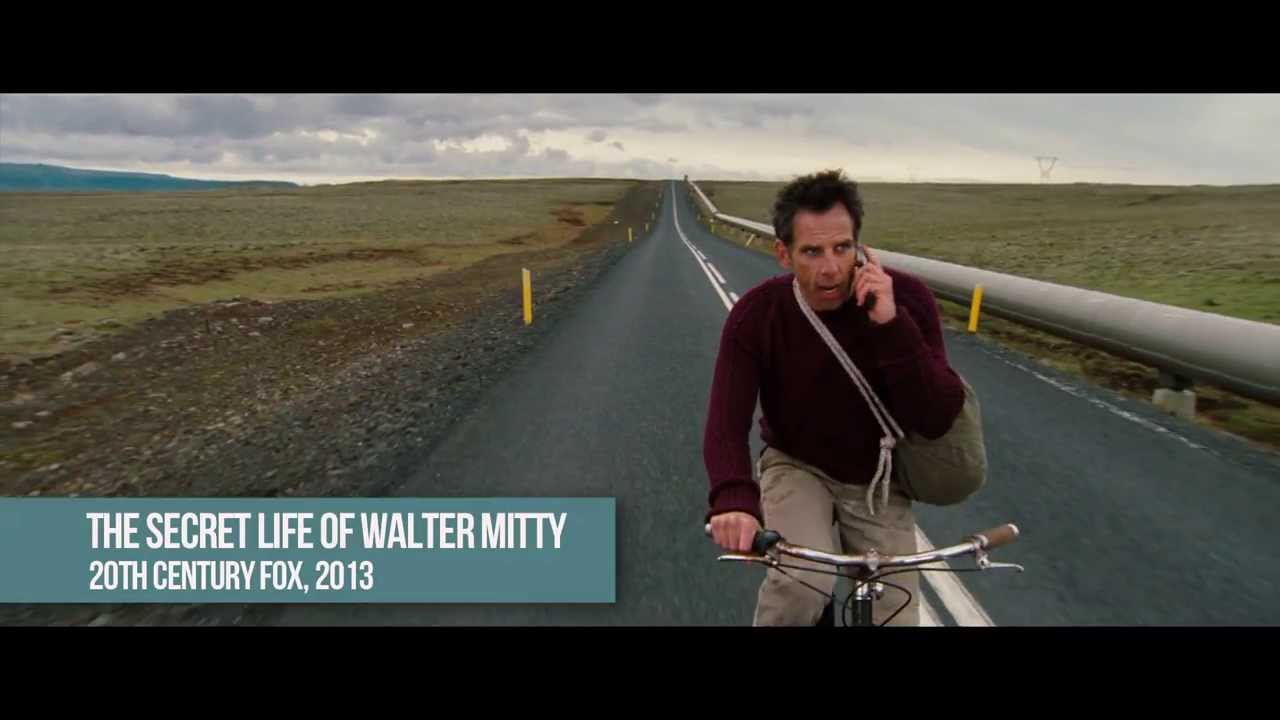Create a short, realistic scenario based on this image. Jacob, a research scientist, left his car behind and opted for his old bicycle after realizing it would be a faster way through the narrow, winding paths leading to the remote testing site. The gloomy skies above promised more rain, but he couldn't risk being late. A critical experiment rested on his shoulders, and even minor delays could result in significant setbacks. As he pedaled through the desolate landscape, he constantly checked his phone for updates, trying to coordinate with his team despite the spotty reception. 